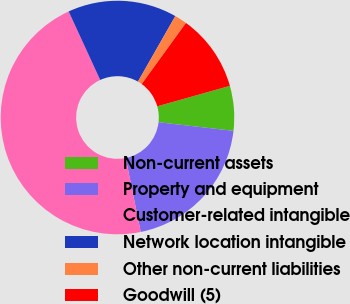Convert chart to OTSL. <chart><loc_0><loc_0><loc_500><loc_500><pie_chart><fcel>Non-current assets<fcel>Property and equipment<fcel>Customer-related intangible<fcel>Network location intangible<fcel>Other non-current liabilities<fcel>Goodwill (5)<nl><fcel>6.19%<fcel>19.99%<fcel>46.32%<fcel>15.11%<fcel>1.73%<fcel>10.65%<nl></chart> 